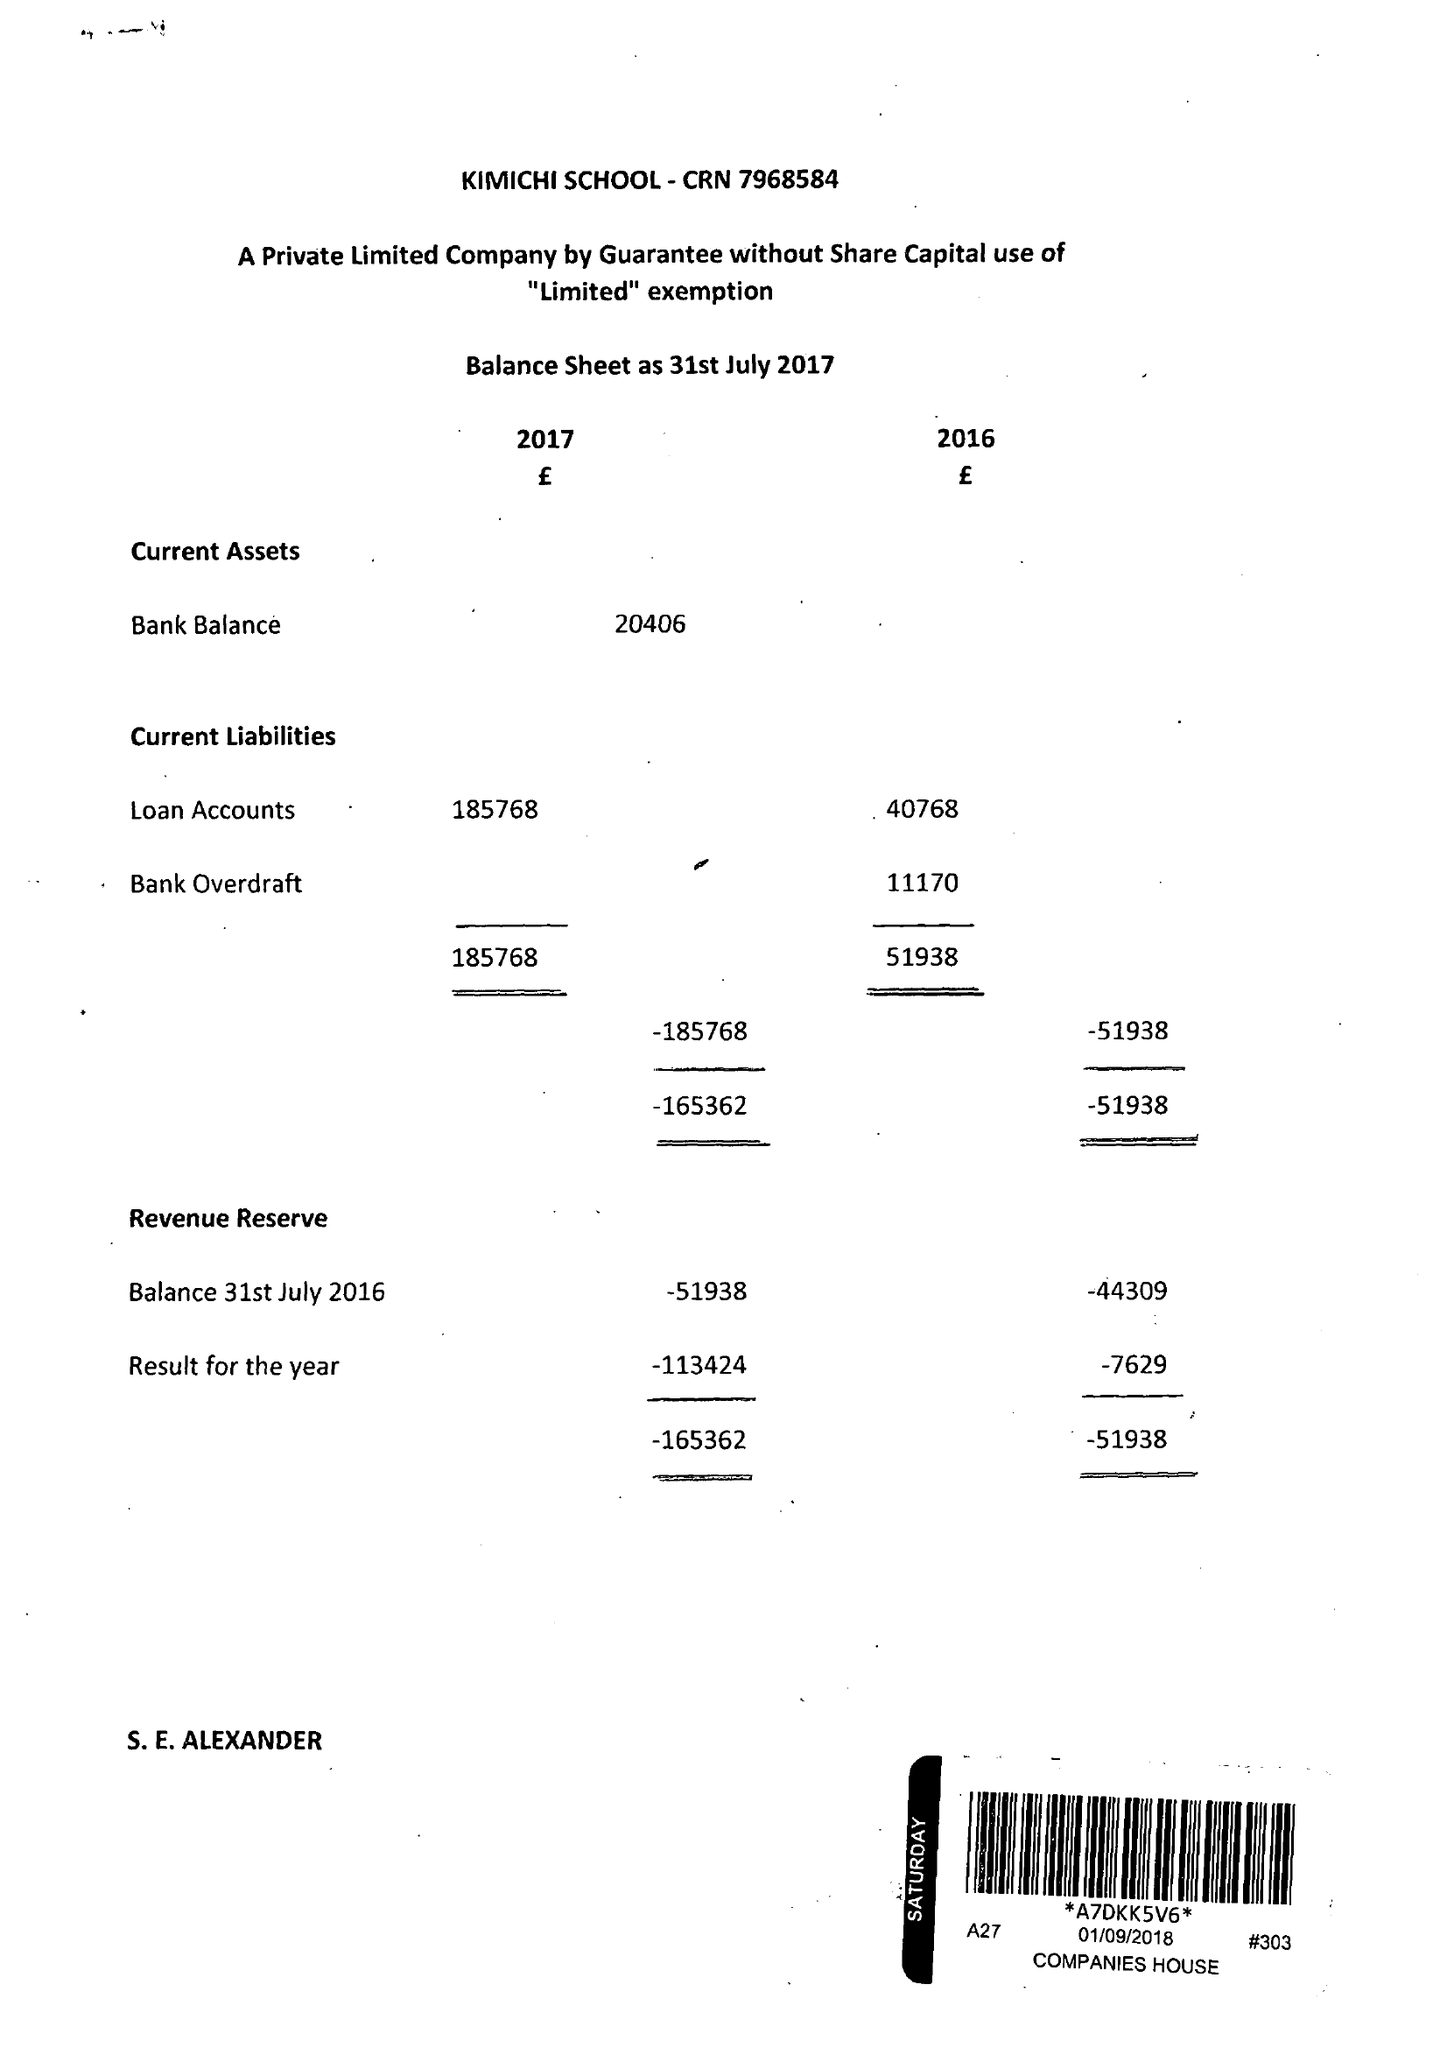What is the value for the charity_number?
Answer the question using a single word or phrase. 1149571 